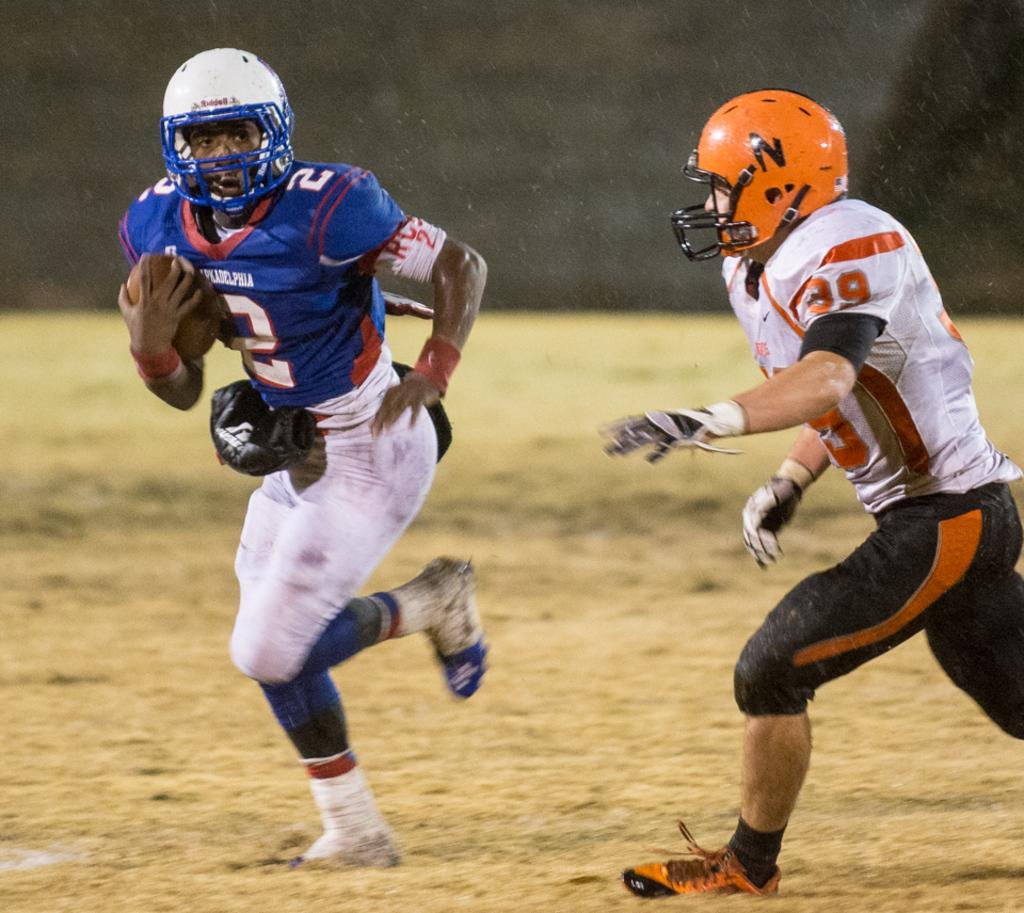What is the man in the image doing? There is a man running in the image. What color is the t-shirt of the first man? The first man is wearing a blue color t-shirt. Are there any other people running in the image? Yes, there is another man running in the image. What color is the t-shirt of the second man? The second man is wearing a white color t-shirt. What additional accessory is the second man wearing? The second man is wearing an orange color helmet. What type of eye can be seen on the helmet of the second man? There is no eye visible on the helmet of the second man in the image. How many eggs are being carried by the first man in the image? There are no eggs present in the image; both men are running without any visible objects. 